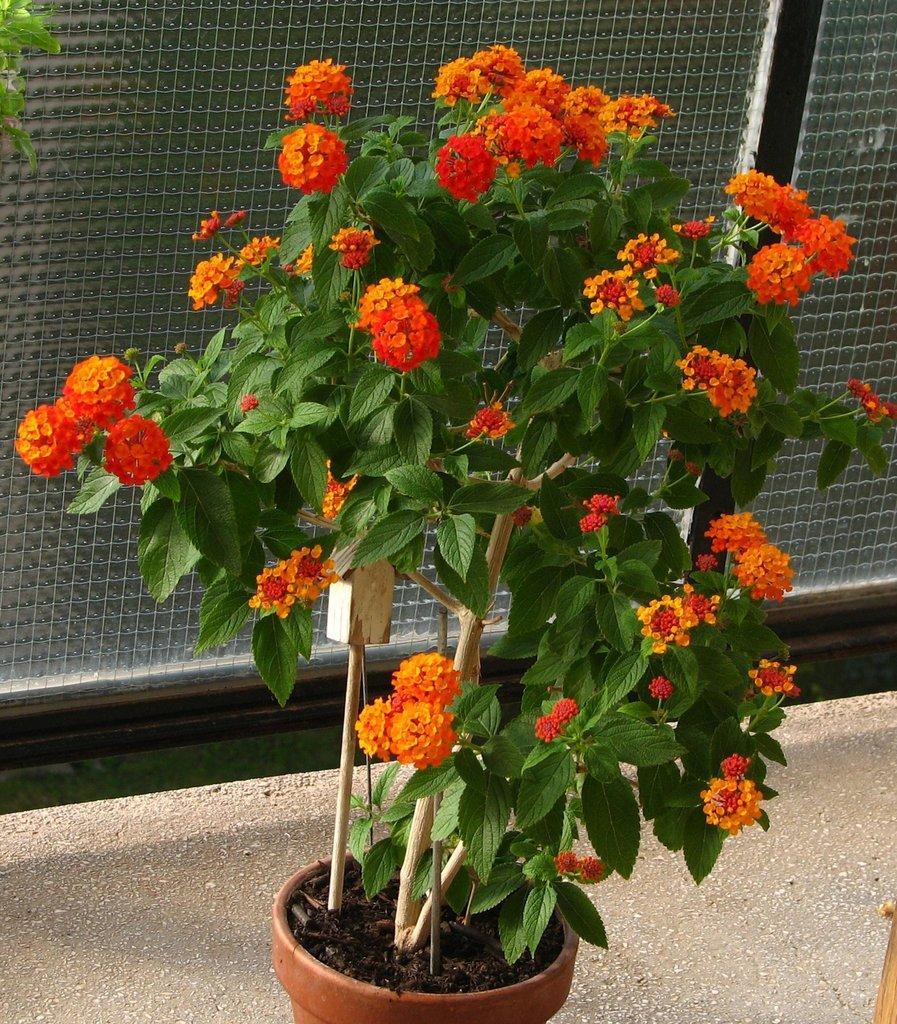Please provide a concise description of this image. In the center of the image there is a flower plant. At the bottom of the image there is road. In the background of the image there is glass fencing. 